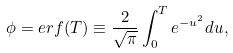<formula> <loc_0><loc_0><loc_500><loc_500>\phi = e r f ( T ) \equiv \frac { 2 } { \sqrt { \pi } } \int _ { 0 } ^ { T } e ^ { - u ^ { 2 } } d u ,</formula> 